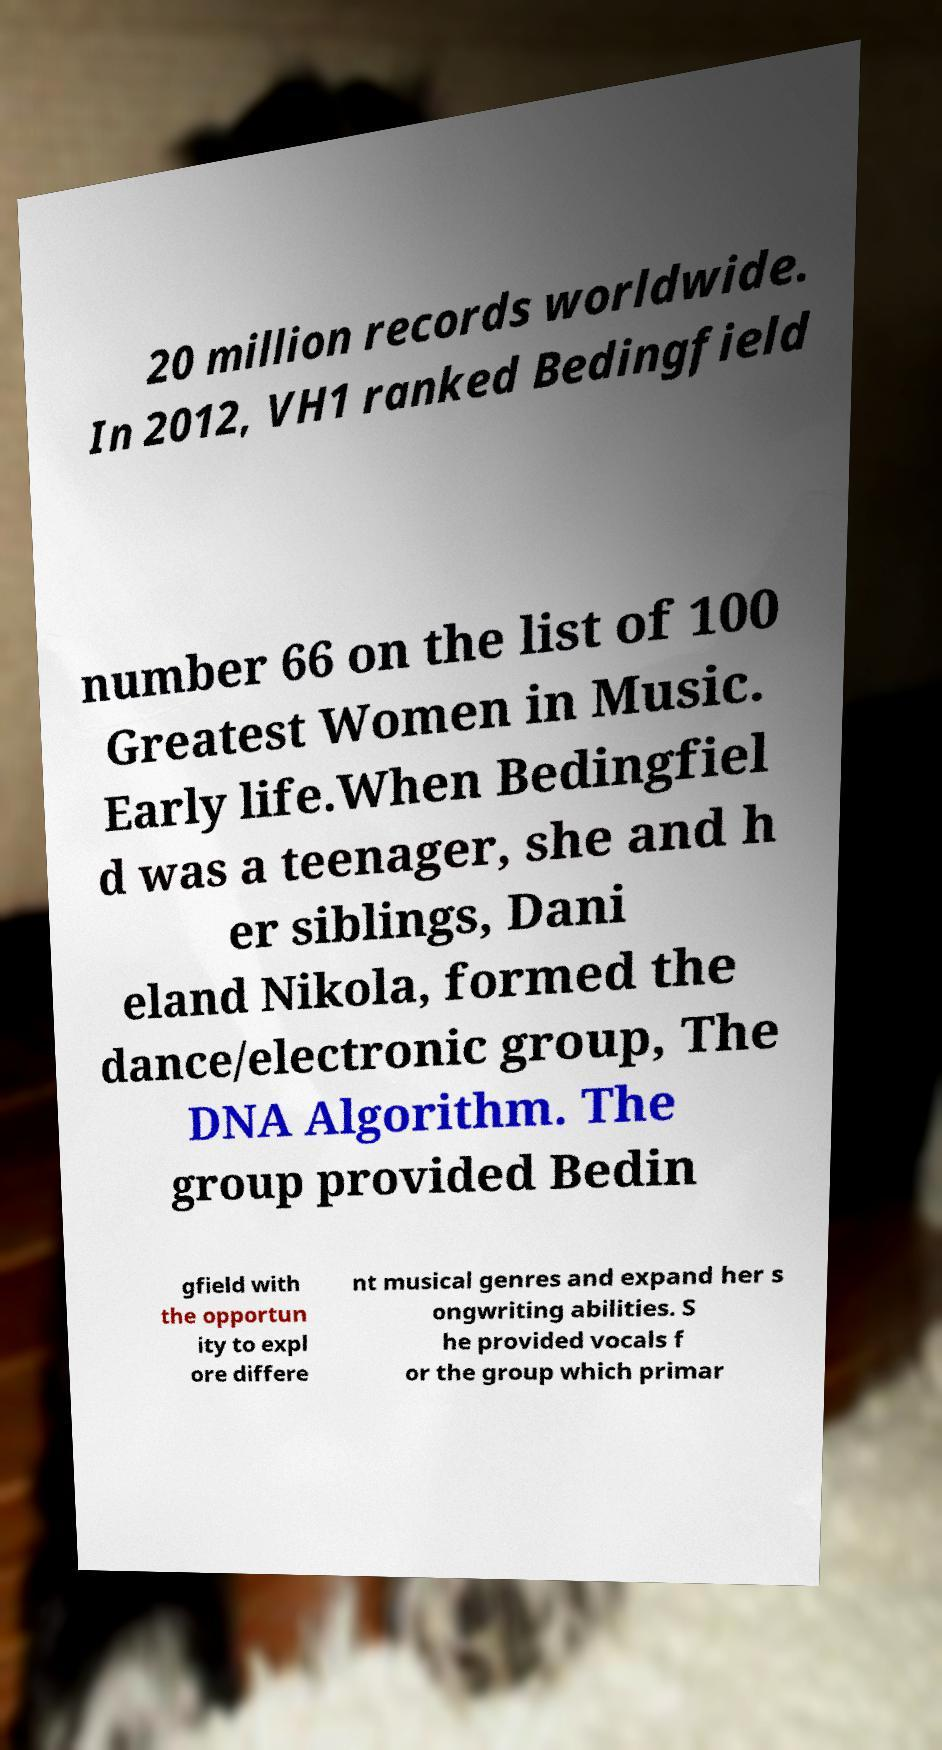I need the written content from this picture converted into text. Can you do that? 20 million records worldwide. In 2012, VH1 ranked Bedingfield number 66 on the list of 100 Greatest Women in Music. Early life.When Bedingfiel d was a teenager, she and h er siblings, Dani eland Nikola, formed the dance/electronic group, The DNA Algorithm. The group provided Bedin gfield with the opportun ity to expl ore differe nt musical genres and expand her s ongwriting abilities. S he provided vocals f or the group which primar 